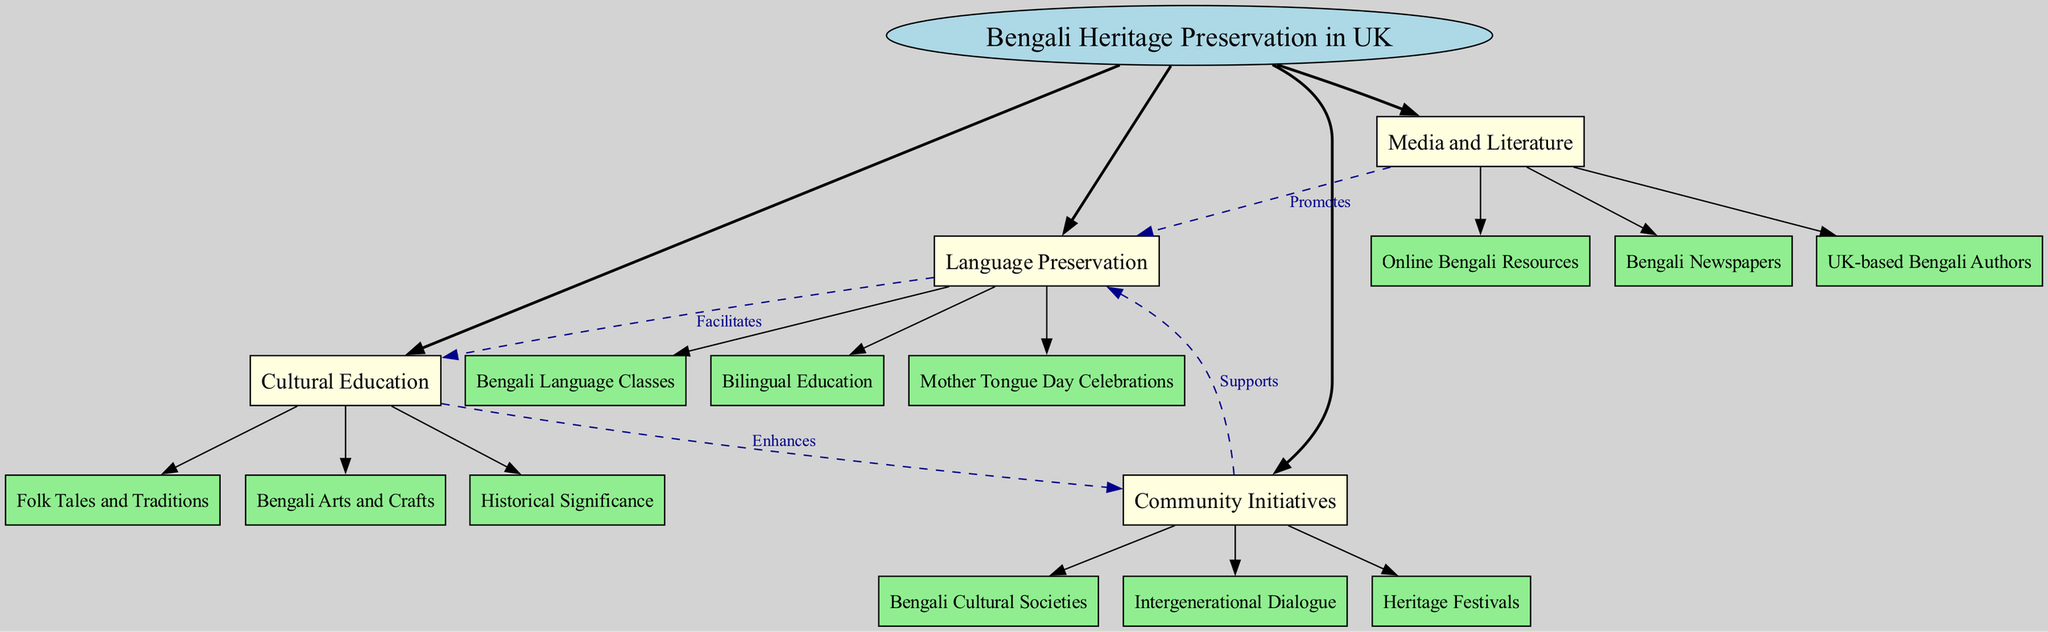What is the central concept of the diagram? The central concept is explicitly stated as "Bengali Heritage Preservation in UK" at the center of the diagram.
Answer: Bengali Heritage Preservation in UK How many main nodes are there? The diagram lists four main nodes branching out from the central concept. Counting them gives the total.
Answer: 4 What supports language preservation according to the diagram? The diagram indicates that "Community Initiatives" supports "Language Preservation" through a labeled connection.
Answer: Community Initiatives Which node facilitates cultural education? The diagram shows that "Language Preservation" facilitates "Cultural Education," as indicated by the labeled edge between the two nodes.
Answer: Language Preservation What are two sub-nodes under 'Media and Literature'? By examining the sub-nodes under "Media and Literature," two can be identified: "Bengali Newspapers" and "UK-based Bengali Authors."
Answer: Bengali Newspapers, UK-based Bengali Authors How does cultural education enhance community initiatives? The diagram presents a connection indicating that "Cultural Education" enhances "Community Initiatives," suggesting an improving relationship.
Answer: Enhances Which node promotes language preservation? The diagram specifies that "Media and Literature" promotes "Language Preservation" through a labeled connection indicating this relationship.
Answer: Media and Literature What kind of education is represented as part of cultural education? The sub-node under "Cultural Education" shows "Folk Tales and Traditions" as a type of education represented in the diagram.
Answer: Folk Tales and Traditions How many sub-nodes does "Language Preservation" have? By examining the "Language Preservation" node, we can list its three sub-nodes, confirming the quantity.
Answer: 3 Which sub-node lists activities involving festivals? The sub-node "Heritage Festivals" under "Community Initiatives" refers to activities involving festivals as part of the diagram's connections.
Answer: Heritage Festivals 